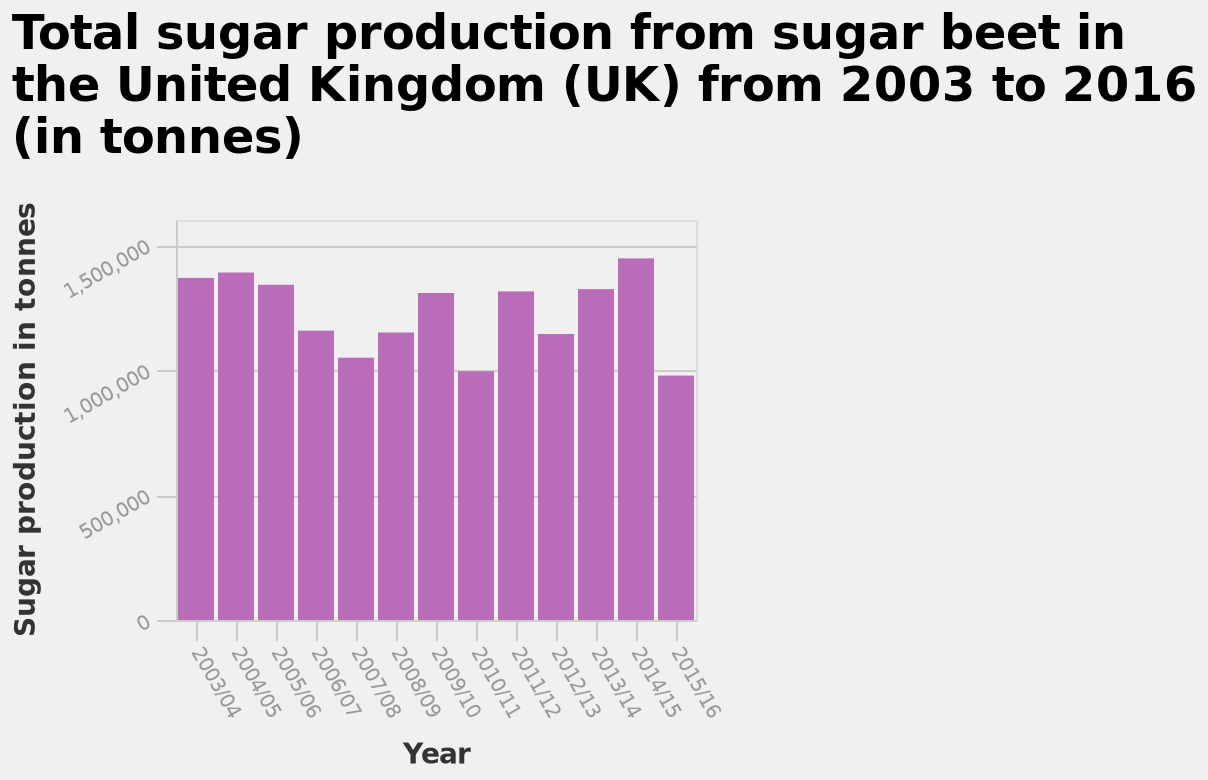<image>
What was the highest production level during the given period?  The highest production level during the given period was 15,000,000 tonnes. Was there any significant change in production between 2003 and 2015/2016? Yes, the production experienced a significant decline in 2010/2011 and 2015/2016, falling below the 10,000,000 mark. In which years did the production fall below 10,000,000 tonnes?  The production fell below 10,000,000 tonnes in 2010/2011 and 2015/2016. What was the average production level between 2003 and 2010/2011?  The average production level between 2003 and 2010/2011 was between 10,000,000 tonnes and 15,000,000 tonnes. How is sugar production measured on the y-axis of the bar graph? Sugar production is measured on a linear scale in tonnes. What is the minimum value of sugar production shown on the y-axis of the bar graph?  The minimum value of sugar production shown on the y-axis is 0 tonnes. 